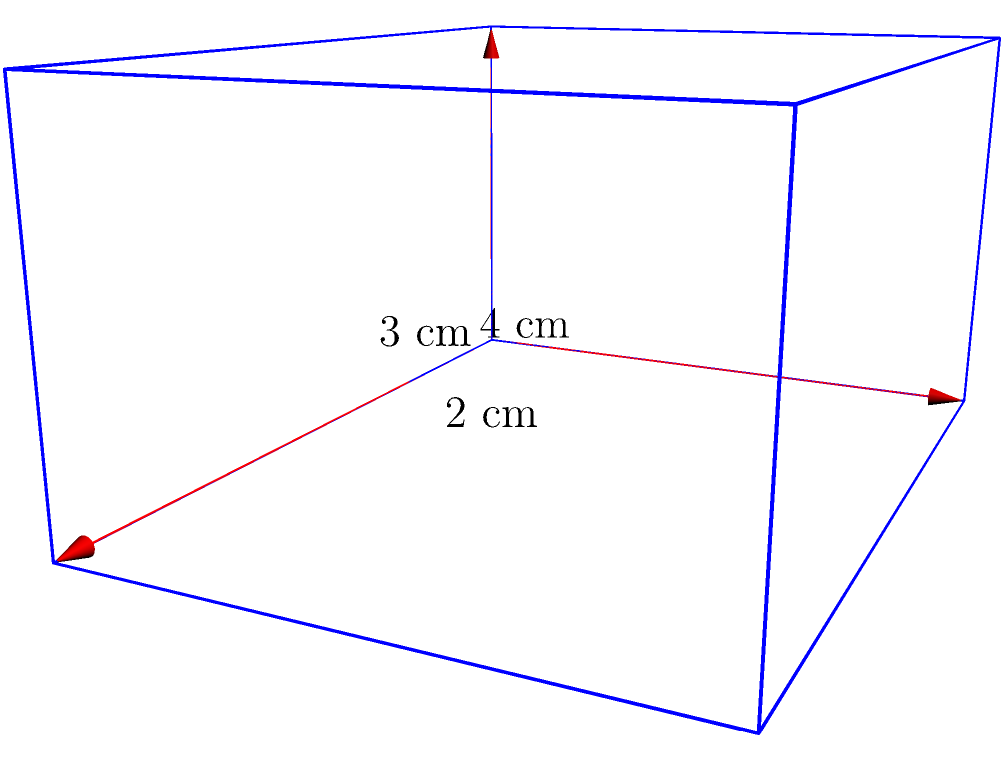In your latest novel, the protagonist discovers a mysterious box in an old attic. The box is a rectangular prism with dimensions 4 cm in length, 3 cm in width, and 2 cm in height. What is the volume of this intriguing box that might hold the key to the story's mystery? To calculate the volume of a rectangular prism, we use the formula:

$$V = l \times w \times h$$

Where:
$V$ = volume
$l$ = length
$w$ = width
$h$ = height

Given the dimensions:
$l = 4$ cm
$w = 3$ cm
$h = 2$ cm

Let's substitute these values into the formula:

$$V = 4 \text{ cm} \times 3 \text{ cm} \times 2 \text{ cm}$$

Now, let's multiply:

$$V = 24 \text{ cm}^3$$

Therefore, the volume of the rectangular prism (the mysterious box) is 24 cubic centimeters.
Answer: $24 \text{ cm}^3$ 